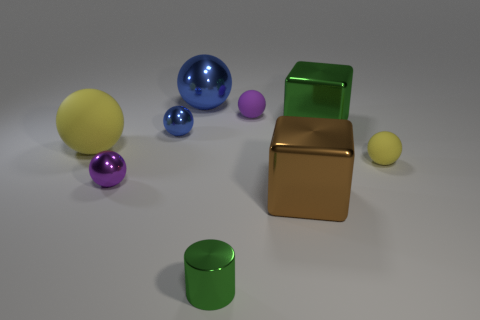There is a yellow matte thing in front of the large yellow matte sphere; is it the same shape as the tiny rubber thing behind the big green shiny object?
Give a very brief answer. Yes. There is a yellow rubber sphere that is on the right side of the metallic block that is in front of the matte sphere that is to the left of the tiny purple metal object; what is its size?
Provide a succinct answer. Small. How big is the green metal object that is behind the large brown thing?
Offer a terse response. Large. There is a small purple sphere on the right side of the tiny green shiny cylinder; what material is it?
Offer a terse response. Rubber. How many green things are either large metal spheres or tiny cylinders?
Your answer should be very brief. 1. Is the small cylinder made of the same material as the yellow thing to the left of the purple shiny thing?
Offer a terse response. No. Are there an equal number of small green things that are on the left side of the small blue sphere and big brown metal objects in front of the green cylinder?
Offer a very short reply. Yes. Is the size of the purple shiny sphere the same as the green object on the right side of the green cylinder?
Your response must be concise. No. Are there more blue shiny objects in front of the small purple rubber thing than brown shiny blocks?
Offer a very short reply. No. How many blocks have the same size as the cylinder?
Provide a short and direct response. 0. 